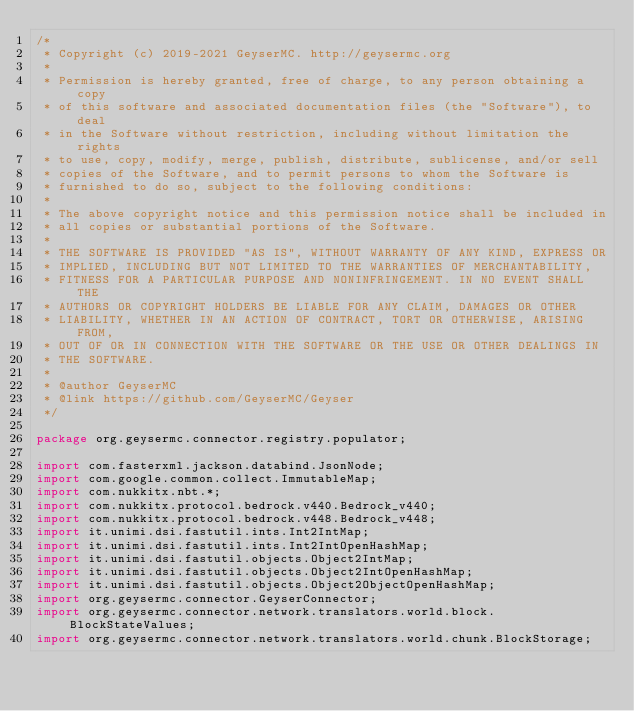Convert code to text. <code><loc_0><loc_0><loc_500><loc_500><_Java_>/*
 * Copyright (c) 2019-2021 GeyserMC. http://geysermc.org
 *
 * Permission is hereby granted, free of charge, to any person obtaining a copy
 * of this software and associated documentation files (the "Software"), to deal
 * in the Software without restriction, including without limitation the rights
 * to use, copy, modify, merge, publish, distribute, sublicense, and/or sell
 * copies of the Software, and to permit persons to whom the Software is
 * furnished to do so, subject to the following conditions:
 *
 * The above copyright notice and this permission notice shall be included in
 * all copies or substantial portions of the Software.
 *
 * THE SOFTWARE IS PROVIDED "AS IS", WITHOUT WARRANTY OF ANY KIND, EXPRESS OR
 * IMPLIED, INCLUDING BUT NOT LIMITED TO THE WARRANTIES OF MERCHANTABILITY,
 * FITNESS FOR A PARTICULAR PURPOSE AND NONINFRINGEMENT. IN NO EVENT SHALL THE
 * AUTHORS OR COPYRIGHT HOLDERS BE LIABLE FOR ANY CLAIM, DAMAGES OR OTHER
 * LIABILITY, WHETHER IN AN ACTION OF CONTRACT, TORT OR OTHERWISE, ARISING FROM,
 * OUT OF OR IN CONNECTION WITH THE SOFTWARE OR THE USE OR OTHER DEALINGS IN
 * THE SOFTWARE.
 *
 * @author GeyserMC
 * @link https://github.com/GeyserMC/Geyser
 */

package org.geysermc.connector.registry.populator;

import com.fasterxml.jackson.databind.JsonNode;
import com.google.common.collect.ImmutableMap;
import com.nukkitx.nbt.*;
import com.nukkitx.protocol.bedrock.v440.Bedrock_v440;
import com.nukkitx.protocol.bedrock.v448.Bedrock_v448;
import it.unimi.dsi.fastutil.ints.Int2IntMap;
import it.unimi.dsi.fastutil.ints.Int2IntOpenHashMap;
import it.unimi.dsi.fastutil.objects.Object2IntMap;
import it.unimi.dsi.fastutil.objects.Object2IntOpenHashMap;
import it.unimi.dsi.fastutil.objects.Object2ObjectOpenHashMap;
import org.geysermc.connector.GeyserConnector;
import org.geysermc.connector.network.translators.world.block.BlockStateValues;
import org.geysermc.connector.network.translators.world.chunk.BlockStorage;</code> 